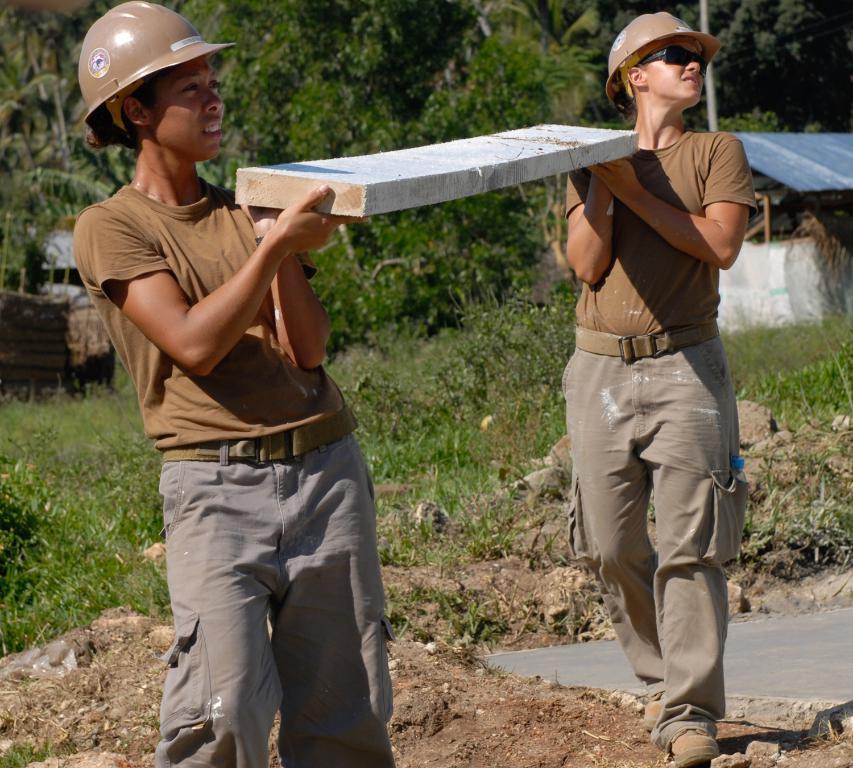How would you summarize this image in a sentence or two? Two people are standing holding stone, there are trees, this is mud. 